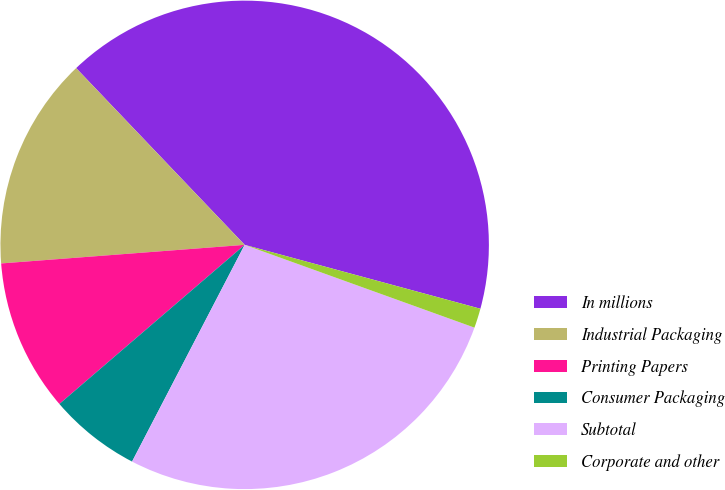Convert chart. <chart><loc_0><loc_0><loc_500><loc_500><pie_chart><fcel>In millions<fcel>Industrial Packaging<fcel>Printing Papers<fcel>Consumer Packaging<fcel>Subtotal<fcel>Corporate and other<nl><fcel>41.33%<fcel>14.09%<fcel>10.08%<fcel>6.08%<fcel>27.12%<fcel>1.29%<nl></chart> 